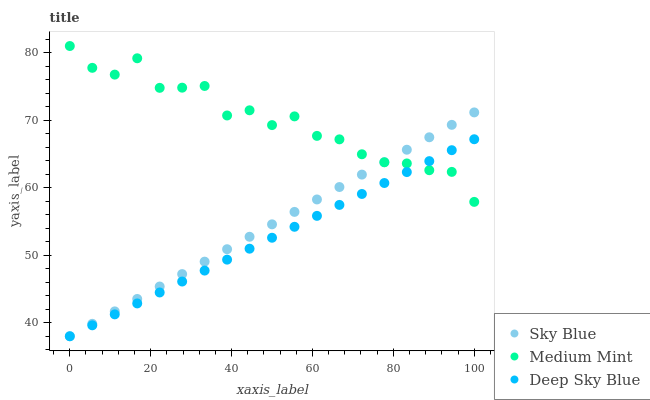Does Deep Sky Blue have the minimum area under the curve?
Answer yes or no. Yes. Does Medium Mint have the maximum area under the curve?
Answer yes or no. Yes. Does Sky Blue have the minimum area under the curve?
Answer yes or no. No. Does Sky Blue have the maximum area under the curve?
Answer yes or no. No. Is Sky Blue the smoothest?
Answer yes or no. Yes. Is Medium Mint the roughest?
Answer yes or no. Yes. Is Deep Sky Blue the smoothest?
Answer yes or no. No. Is Deep Sky Blue the roughest?
Answer yes or no. No. Does Sky Blue have the lowest value?
Answer yes or no. Yes. Does Medium Mint have the highest value?
Answer yes or no. Yes. Does Sky Blue have the highest value?
Answer yes or no. No. Does Sky Blue intersect Deep Sky Blue?
Answer yes or no. Yes. Is Sky Blue less than Deep Sky Blue?
Answer yes or no. No. Is Sky Blue greater than Deep Sky Blue?
Answer yes or no. No. 